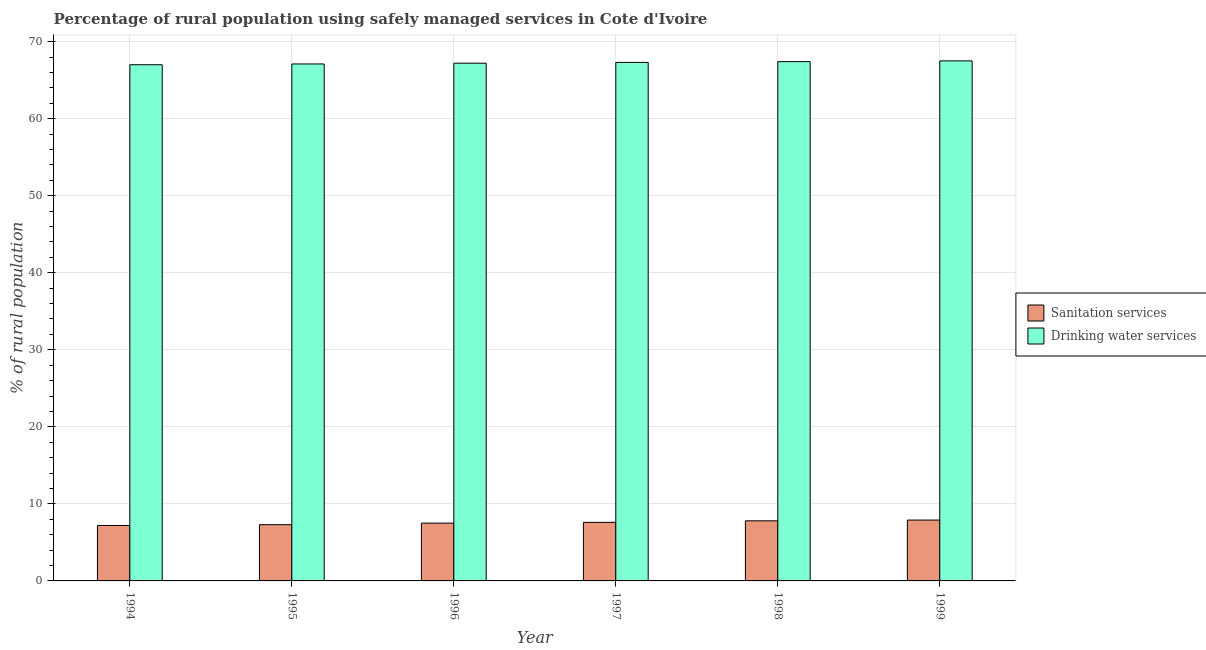How many different coloured bars are there?
Keep it short and to the point. 2. Are the number of bars per tick equal to the number of legend labels?
Your response must be concise. Yes. How many bars are there on the 3rd tick from the right?
Your answer should be compact. 2. In how many cases, is the number of bars for a given year not equal to the number of legend labels?
Your answer should be compact. 0. Across all years, what is the maximum percentage of rural population who used drinking water services?
Your response must be concise. 67.5. What is the total percentage of rural population who used sanitation services in the graph?
Offer a very short reply. 45.3. What is the difference between the percentage of rural population who used sanitation services in 1995 and that in 1999?
Provide a short and direct response. -0.6. What is the difference between the percentage of rural population who used sanitation services in 1996 and the percentage of rural population who used drinking water services in 1994?
Your response must be concise. 0.3. What is the average percentage of rural population who used sanitation services per year?
Keep it short and to the point. 7.55. In how many years, is the percentage of rural population who used sanitation services greater than 14 %?
Ensure brevity in your answer.  0. What is the ratio of the percentage of rural population who used drinking water services in 1996 to that in 1998?
Provide a short and direct response. 1. What is the difference between the highest and the second highest percentage of rural population who used drinking water services?
Make the answer very short. 0.1. In how many years, is the percentage of rural population who used sanitation services greater than the average percentage of rural population who used sanitation services taken over all years?
Give a very brief answer. 3. What does the 2nd bar from the left in 1996 represents?
Provide a succinct answer. Drinking water services. What does the 1st bar from the right in 1994 represents?
Keep it short and to the point. Drinking water services. How many bars are there?
Make the answer very short. 12. Are all the bars in the graph horizontal?
Offer a terse response. No. Does the graph contain any zero values?
Offer a terse response. No. Where does the legend appear in the graph?
Keep it short and to the point. Center right. How many legend labels are there?
Provide a succinct answer. 2. How are the legend labels stacked?
Keep it short and to the point. Vertical. What is the title of the graph?
Provide a succinct answer. Percentage of rural population using safely managed services in Cote d'Ivoire. Does "Manufacturing industries and construction" appear as one of the legend labels in the graph?
Offer a terse response. No. What is the label or title of the Y-axis?
Your answer should be very brief. % of rural population. What is the % of rural population of Drinking water services in 1994?
Offer a very short reply. 67. What is the % of rural population of Drinking water services in 1995?
Your response must be concise. 67.1. What is the % of rural population of Sanitation services in 1996?
Ensure brevity in your answer.  7.5. What is the % of rural population in Drinking water services in 1996?
Offer a terse response. 67.2. What is the % of rural population of Drinking water services in 1997?
Make the answer very short. 67.3. What is the % of rural population in Drinking water services in 1998?
Provide a succinct answer. 67.4. What is the % of rural population in Drinking water services in 1999?
Ensure brevity in your answer.  67.5. Across all years, what is the maximum % of rural population in Sanitation services?
Ensure brevity in your answer.  7.9. Across all years, what is the maximum % of rural population of Drinking water services?
Keep it short and to the point. 67.5. Across all years, what is the minimum % of rural population in Drinking water services?
Keep it short and to the point. 67. What is the total % of rural population in Sanitation services in the graph?
Your response must be concise. 45.3. What is the total % of rural population of Drinking water services in the graph?
Your answer should be compact. 403.5. What is the difference between the % of rural population in Sanitation services in 1994 and that in 1995?
Offer a very short reply. -0.1. What is the difference between the % of rural population of Sanitation services in 1994 and that in 1996?
Make the answer very short. -0.3. What is the difference between the % of rural population of Drinking water services in 1994 and that in 1996?
Ensure brevity in your answer.  -0.2. What is the difference between the % of rural population in Sanitation services in 1994 and that in 1997?
Offer a terse response. -0.4. What is the difference between the % of rural population of Drinking water services in 1994 and that in 1997?
Provide a succinct answer. -0.3. What is the difference between the % of rural population in Drinking water services in 1994 and that in 1998?
Your answer should be compact. -0.4. What is the difference between the % of rural population in Sanitation services in 1994 and that in 1999?
Make the answer very short. -0.7. What is the difference between the % of rural population in Drinking water services in 1995 and that in 1996?
Offer a very short reply. -0.1. What is the difference between the % of rural population in Drinking water services in 1995 and that in 1999?
Give a very brief answer. -0.4. What is the difference between the % of rural population of Sanitation services in 1996 and that in 1997?
Keep it short and to the point. -0.1. What is the difference between the % of rural population in Drinking water services in 1996 and that in 1997?
Your response must be concise. -0.1. What is the difference between the % of rural population in Sanitation services in 1996 and that in 1999?
Your answer should be very brief. -0.4. What is the difference between the % of rural population in Drinking water services in 1997 and that in 1999?
Your answer should be very brief. -0.2. What is the difference between the % of rural population of Sanitation services in 1998 and that in 1999?
Your response must be concise. -0.1. What is the difference between the % of rural population of Drinking water services in 1998 and that in 1999?
Your answer should be compact. -0.1. What is the difference between the % of rural population in Sanitation services in 1994 and the % of rural population in Drinking water services in 1995?
Your response must be concise. -59.9. What is the difference between the % of rural population in Sanitation services in 1994 and the % of rural population in Drinking water services in 1996?
Offer a terse response. -60. What is the difference between the % of rural population of Sanitation services in 1994 and the % of rural population of Drinking water services in 1997?
Your response must be concise. -60.1. What is the difference between the % of rural population in Sanitation services in 1994 and the % of rural population in Drinking water services in 1998?
Your answer should be compact. -60.2. What is the difference between the % of rural population in Sanitation services in 1994 and the % of rural population in Drinking water services in 1999?
Make the answer very short. -60.3. What is the difference between the % of rural population of Sanitation services in 1995 and the % of rural population of Drinking water services in 1996?
Your response must be concise. -59.9. What is the difference between the % of rural population of Sanitation services in 1995 and the % of rural population of Drinking water services in 1997?
Give a very brief answer. -60. What is the difference between the % of rural population of Sanitation services in 1995 and the % of rural population of Drinking water services in 1998?
Give a very brief answer. -60.1. What is the difference between the % of rural population of Sanitation services in 1995 and the % of rural population of Drinking water services in 1999?
Make the answer very short. -60.2. What is the difference between the % of rural population of Sanitation services in 1996 and the % of rural population of Drinking water services in 1997?
Provide a succinct answer. -59.8. What is the difference between the % of rural population in Sanitation services in 1996 and the % of rural population in Drinking water services in 1998?
Your response must be concise. -59.9. What is the difference between the % of rural population of Sanitation services in 1996 and the % of rural population of Drinking water services in 1999?
Keep it short and to the point. -60. What is the difference between the % of rural population in Sanitation services in 1997 and the % of rural population in Drinking water services in 1998?
Your answer should be compact. -59.8. What is the difference between the % of rural population of Sanitation services in 1997 and the % of rural population of Drinking water services in 1999?
Keep it short and to the point. -59.9. What is the difference between the % of rural population of Sanitation services in 1998 and the % of rural population of Drinking water services in 1999?
Your answer should be very brief. -59.7. What is the average % of rural population of Sanitation services per year?
Offer a very short reply. 7.55. What is the average % of rural population in Drinking water services per year?
Your answer should be compact. 67.25. In the year 1994, what is the difference between the % of rural population of Sanitation services and % of rural population of Drinking water services?
Keep it short and to the point. -59.8. In the year 1995, what is the difference between the % of rural population of Sanitation services and % of rural population of Drinking water services?
Give a very brief answer. -59.8. In the year 1996, what is the difference between the % of rural population of Sanitation services and % of rural population of Drinking water services?
Provide a succinct answer. -59.7. In the year 1997, what is the difference between the % of rural population of Sanitation services and % of rural population of Drinking water services?
Provide a short and direct response. -59.7. In the year 1998, what is the difference between the % of rural population in Sanitation services and % of rural population in Drinking water services?
Your answer should be compact. -59.6. In the year 1999, what is the difference between the % of rural population in Sanitation services and % of rural population in Drinking water services?
Offer a very short reply. -59.6. What is the ratio of the % of rural population of Sanitation services in 1994 to that in 1995?
Your answer should be very brief. 0.99. What is the ratio of the % of rural population of Drinking water services in 1994 to that in 1996?
Your answer should be compact. 1. What is the ratio of the % of rural population in Sanitation services in 1994 to that in 1999?
Your answer should be compact. 0.91. What is the ratio of the % of rural population of Drinking water services in 1994 to that in 1999?
Your answer should be very brief. 0.99. What is the ratio of the % of rural population in Sanitation services in 1995 to that in 1996?
Your response must be concise. 0.97. What is the ratio of the % of rural population of Sanitation services in 1995 to that in 1997?
Your answer should be compact. 0.96. What is the ratio of the % of rural population in Sanitation services in 1995 to that in 1998?
Provide a succinct answer. 0.94. What is the ratio of the % of rural population in Drinking water services in 1995 to that in 1998?
Make the answer very short. 1. What is the ratio of the % of rural population in Sanitation services in 1995 to that in 1999?
Make the answer very short. 0.92. What is the ratio of the % of rural population in Drinking water services in 1995 to that in 1999?
Offer a terse response. 0.99. What is the ratio of the % of rural population of Drinking water services in 1996 to that in 1997?
Offer a terse response. 1. What is the ratio of the % of rural population in Sanitation services in 1996 to that in 1998?
Your answer should be compact. 0.96. What is the ratio of the % of rural population of Drinking water services in 1996 to that in 1998?
Your response must be concise. 1. What is the ratio of the % of rural population of Sanitation services in 1996 to that in 1999?
Your response must be concise. 0.95. What is the ratio of the % of rural population of Sanitation services in 1997 to that in 1998?
Ensure brevity in your answer.  0.97. What is the ratio of the % of rural population in Drinking water services in 1997 to that in 1998?
Offer a very short reply. 1. What is the ratio of the % of rural population in Sanitation services in 1998 to that in 1999?
Provide a short and direct response. 0.99. What is the difference between the highest and the second highest % of rural population in Drinking water services?
Your answer should be very brief. 0.1. What is the difference between the highest and the lowest % of rural population of Sanitation services?
Your answer should be very brief. 0.7. 